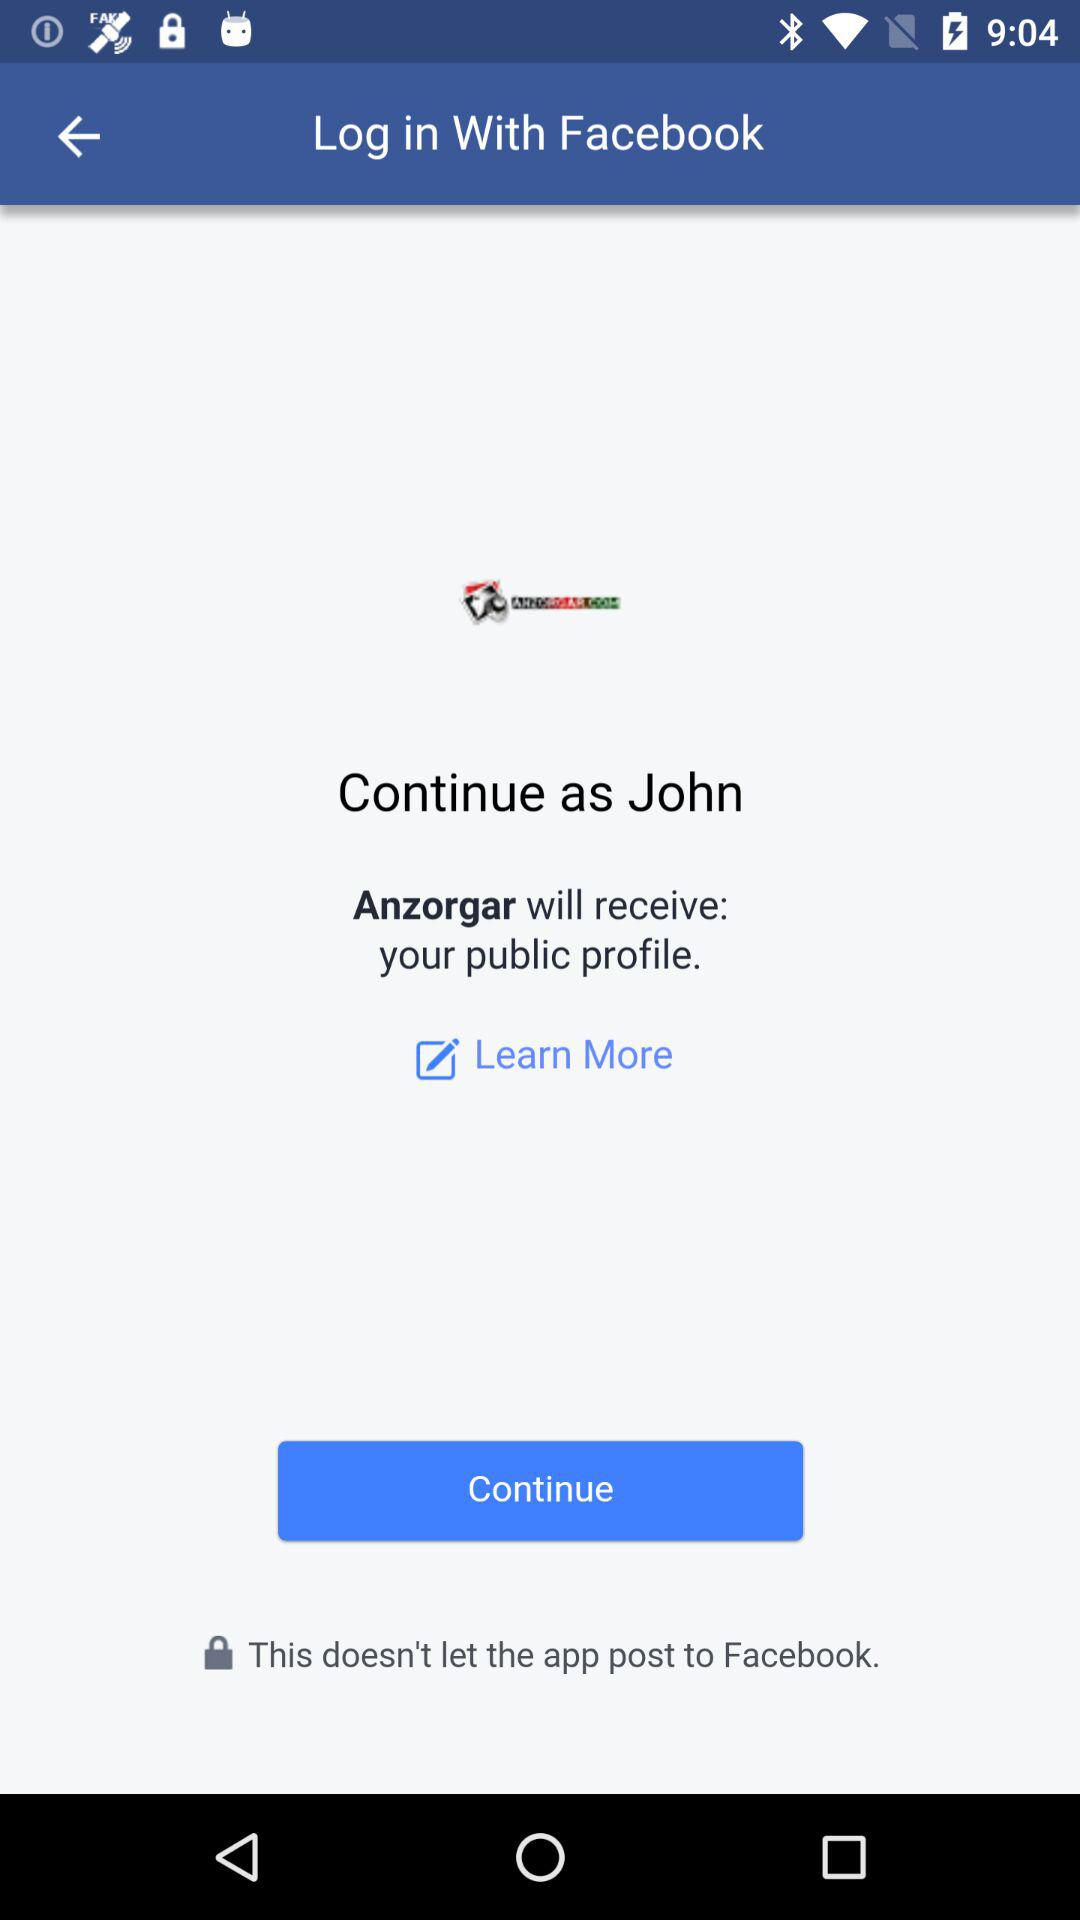What application is asking for permission? The application that is asking for permission is "Anzorgar". 